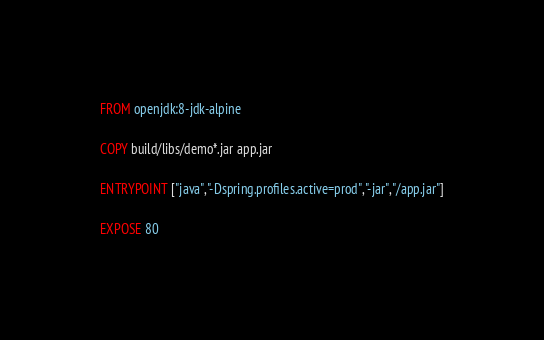<code> <loc_0><loc_0><loc_500><loc_500><_Dockerfile_>FROM openjdk:8-jdk-alpine

COPY build/libs/demo*.jar app.jar

ENTRYPOINT ["java","-Dspring.profiles.active=prod","-jar","/app.jar"]

EXPOSE 80</code> 